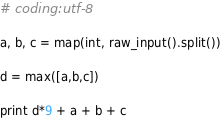Convert code to text. <code><loc_0><loc_0><loc_500><loc_500><_Python_># coding:utf-8

a, b, c = map(int, raw_input().split())

d = max([a,b,c])

print d*9 + a + b + c

</code> 